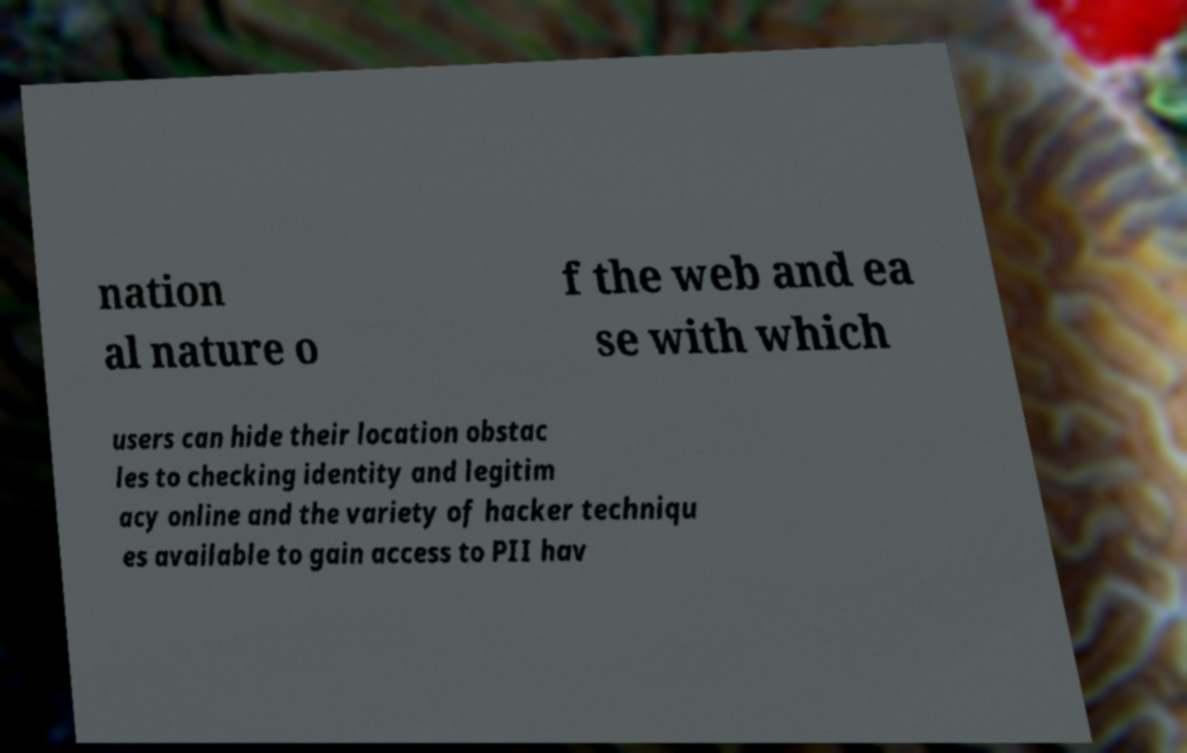For documentation purposes, I need the text within this image transcribed. Could you provide that? nation al nature o f the web and ea se with which users can hide their location obstac les to checking identity and legitim acy online and the variety of hacker techniqu es available to gain access to PII hav 